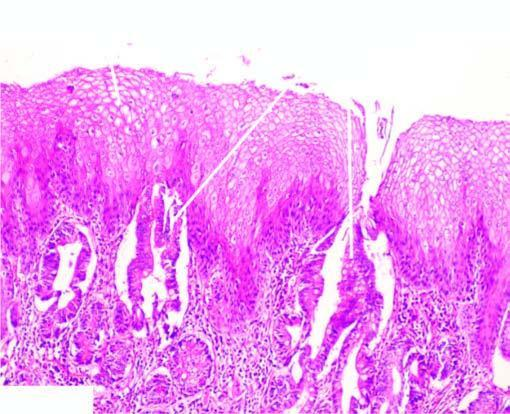does part of the oesophagus which is normally lined by squamous epithelium undergo metaplastic change to columnar epithelium of intestinal type?
Answer the question using a single word or phrase. Yes 